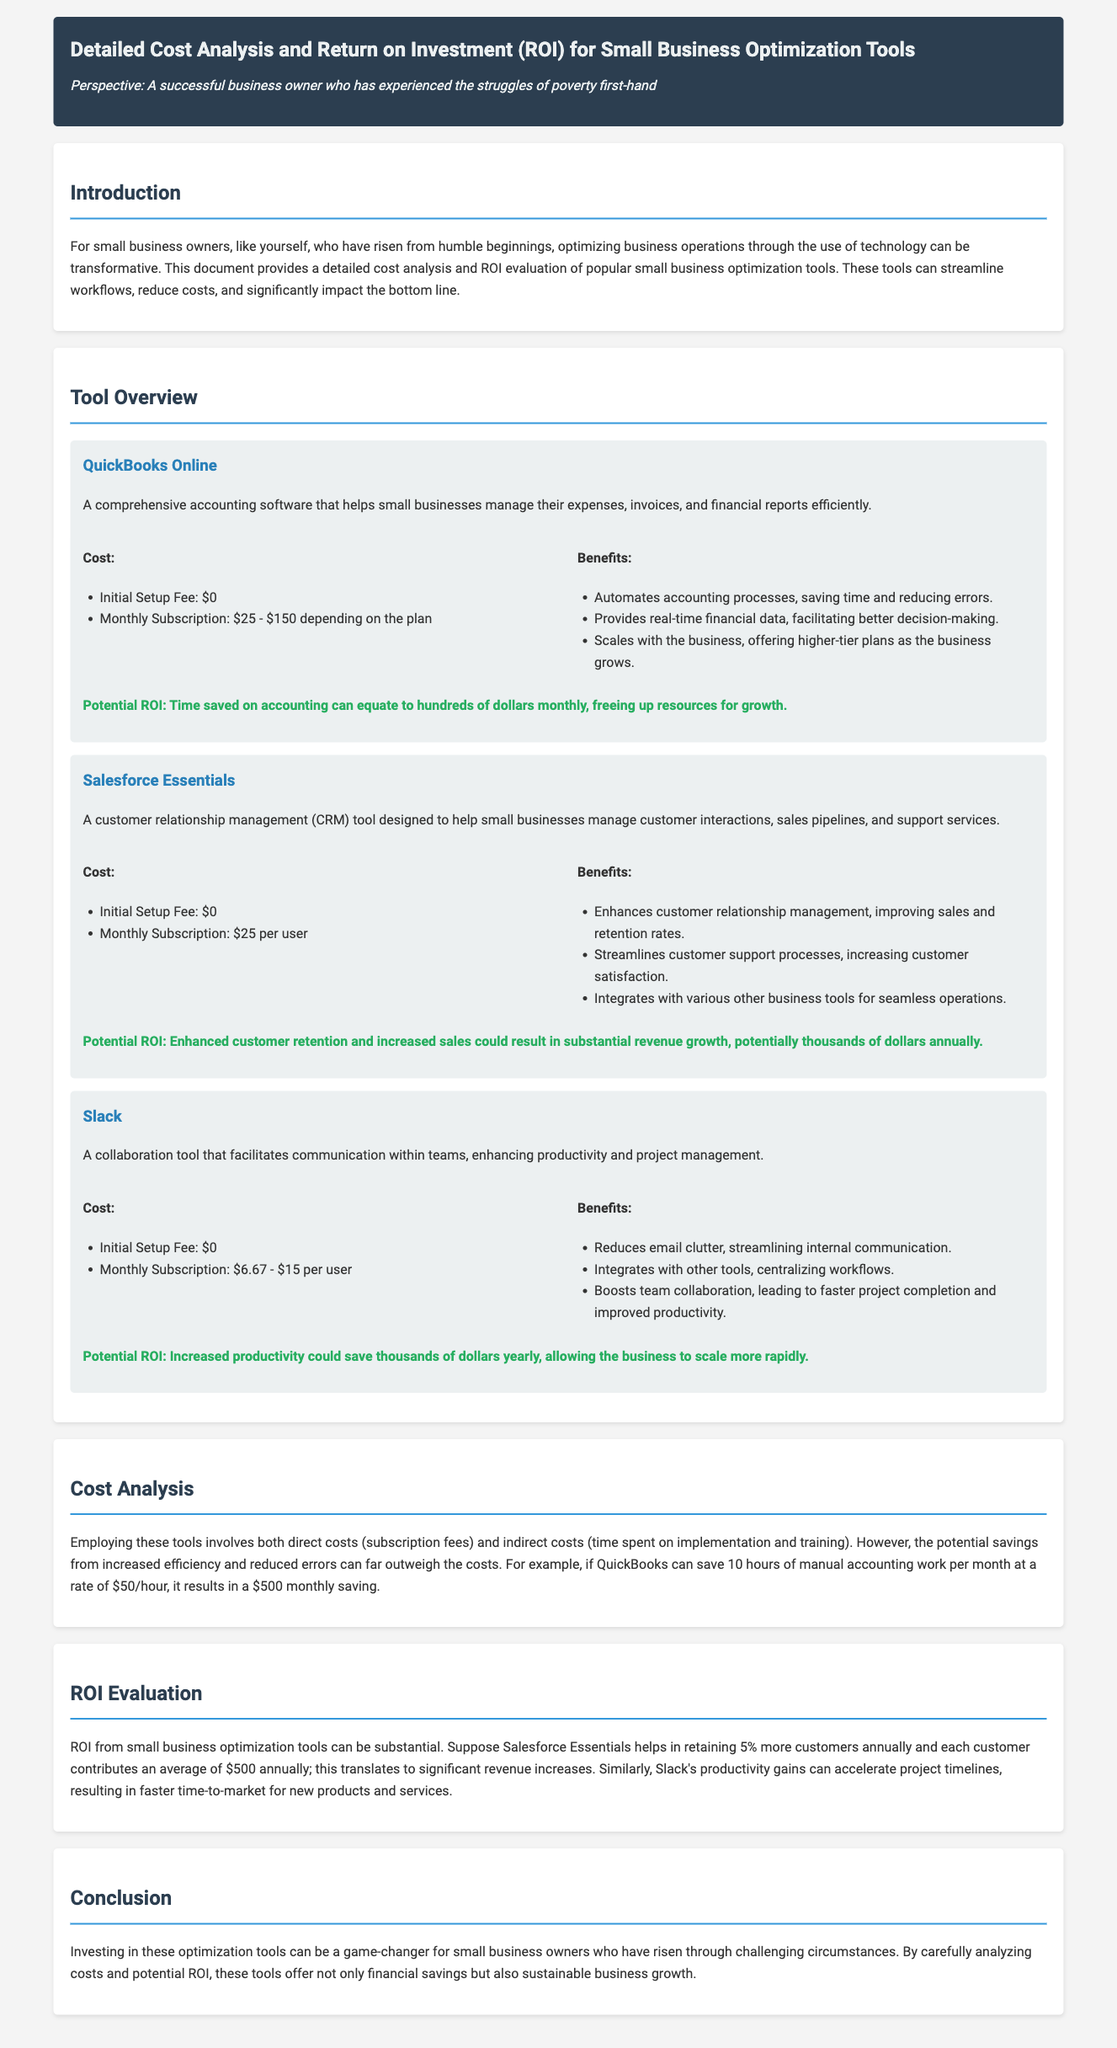what is the monthly subscription cost range for QuickBooks Online? The document states that the monthly subscription for QuickBooks Online is between $25 and $150 depending on the plan.
Answer: $25 - $150 what is the potential ROI for Slack? The potential ROI mentioned for Slack includes increased productivity saving thousands of dollars yearly, allowing the business to scale more rapidly.
Answer: thousands of dollars how much can QuickBooks potentially save monthly if 10 hours are saved? The document suggests that if 10 hours of manual accounting work can be saved at a rate of $50 per hour, it results in a $500 monthly saving.
Answer: $500 which tool is designed for customer relationship management? The document states that Salesforce Essentials is a customer relationship management (CRM) tool.
Answer: Salesforce Essentials what is the initial setup fee for Salesforce Essentials? The document lists the initial setup fee for Salesforce Essentials as $0.
Answer: $0 how does the implementation of these tools affect customer retention according to the document? The document indicates that Salesforce Essentials helps retain 5% more customers annually, leading to significant revenue increases.
Answer: 5% what is the main purpose of Slack? Slack is described in the document as a collaboration tool that facilitates communication within teams.
Answer: communication what is the cost of Slack’s monthly subscription per user? The monthly subscription cost for Slack is given as between $6.67 and $15 per user.
Answer: $6.67 - $15 how does the document suggest small business owners could benefit from these tools? The document suggests that investing in these optimization tools offers not only financial savings but also sustainable business growth.
Answer: financial savings and sustainable business growth 